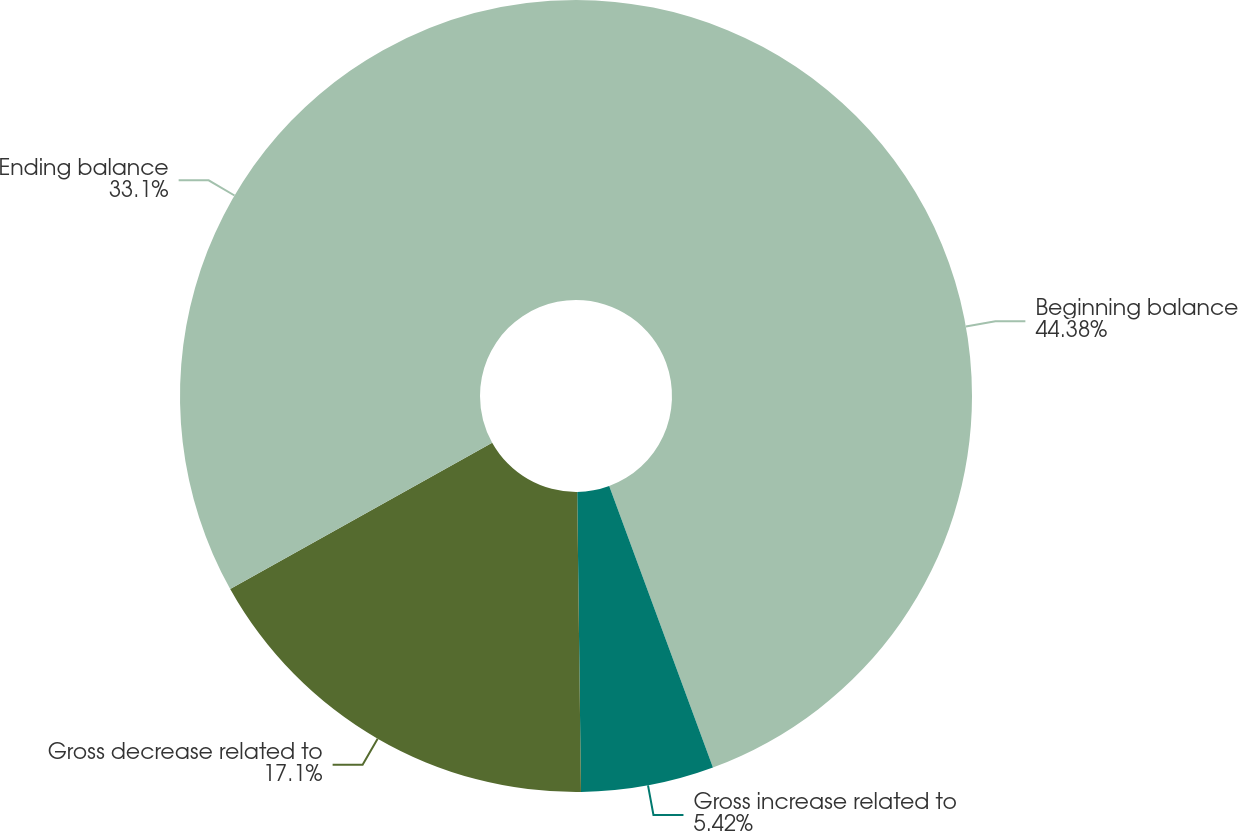<chart> <loc_0><loc_0><loc_500><loc_500><pie_chart><fcel>Beginning balance<fcel>Gross increase related to<fcel>Gross decrease related to<fcel>Ending balance<nl><fcel>44.38%<fcel>5.42%<fcel>17.1%<fcel>33.1%<nl></chart> 